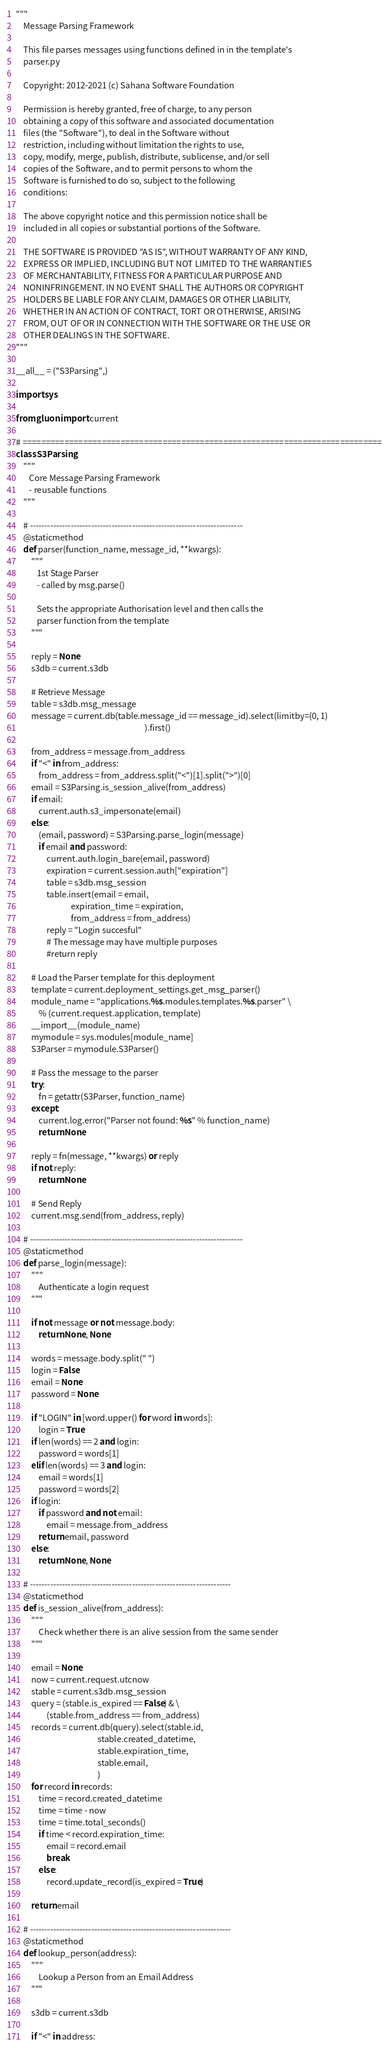<code> <loc_0><loc_0><loc_500><loc_500><_Python_>"""
    Message Parsing Framework

    This file parses messages using functions defined in in the template's
    parser.py

    Copyright: 2012-2021 (c) Sahana Software Foundation

    Permission is hereby granted, free of charge, to any person
    obtaining a copy of this software and associated documentation
    files (the "Software"), to deal in the Software without
    restriction, including without limitation the rights to use,
    copy, modify, merge, publish, distribute, sublicense, and/or sell
    copies of the Software, and to permit persons to whom the
    Software is furnished to do so, subject to the following
    conditions:

    The above copyright notice and this permission notice shall be
    included in all copies or substantial portions of the Software.

    THE SOFTWARE IS PROVIDED "AS IS", WITHOUT WARRANTY OF ANY KIND,
    EXPRESS OR IMPLIED, INCLUDING BUT NOT LIMITED TO THE WARRANTIES
    OF MERCHANTABILITY, FITNESS FOR A PARTICULAR PURPOSE AND
    NONINFRINGEMENT. IN NO EVENT SHALL THE AUTHORS OR COPYRIGHT
    HOLDERS BE LIABLE FOR ANY CLAIM, DAMAGES OR OTHER LIABILITY,
    WHETHER IN AN ACTION OF CONTRACT, TORT OR OTHERWISE, ARISING
    FROM, OUT OF OR IN CONNECTION WITH THE SOFTWARE OR THE USE OR
    OTHER DEALINGS IN THE SOFTWARE.
"""

__all__ = ("S3Parsing",)

import sys

from gluon import current

# =============================================================================
class S3Parsing:
    """
       Core Message Parsing Framework
       - reusable functions
    """

    # -------------------------------------------------------------------------
    @staticmethod
    def parser(function_name, message_id, **kwargs):
        """
           1st Stage Parser
           - called by msg.parse()

           Sets the appropriate Authorisation level and then calls the
           parser function from the template
        """

        reply = None
        s3db = current.s3db

        # Retrieve Message
        table = s3db.msg_message
        message = current.db(table.message_id == message_id).select(limitby=(0, 1)
                                                                    ).first()

        from_address = message.from_address
        if "<" in from_address:
            from_address = from_address.split("<")[1].split(">")[0]
        email = S3Parsing.is_session_alive(from_address)
        if email:
            current.auth.s3_impersonate(email)
        else:
            (email, password) = S3Parsing.parse_login(message)
            if email and password:
                current.auth.login_bare(email, password)
                expiration = current.session.auth["expiration"]
                table = s3db.msg_session
                table.insert(email = email,
                             expiration_time = expiration,
                             from_address = from_address)
                reply = "Login succesful"
                # The message may have multiple purposes
                #return reply

        # Load the Parser template for this deployment
        template = current.deployment_settings.get_msg_parser()
        module_name = "applications.%s.modules.templates.%s.parser" \
            % (current.request.application, template)
        __import__(module_name)
        mymodule = sys.modules[module_name]
        S3Parser = mymodule.S3Parser()

        # Pass the message to the parser
        try:
            fn = getattr(S3Parser, function_name)
        except:
            current.log.error("Parser not found: %s" % function_name)
            return None

        reply = fn(message, **kwargs) or reply
        if not reply:
            return None

        # Send Reply
        current.msg.send(from_address, reply)

    # -------------------------------------------------------------------------
    @staticmethod
    def parse_login(message):
        """
            Authenticate a login request
        """

        if not message or not message.body:
            return None, None

        words = message.body.split(" ")
        login = False
        email = None
        password = None

        if "LOGIN" in [word.upper() for word in words]:
            login = True
        if len(words) == 2 and login:
            password = words[1]
        elif len(words) == 3 and login:
            email = words[1]
            password = words[2]
        if login:
            if password and not email:
                email = message.from_address
            return email, password
        else:
            return None, None

    # ---------------------------------------------------------------------
    @staticmethod
    def is_session_alive(from_address):
        """
            Check whether there is an alive session from the same sender
        """

        email = None
        now = current.request.utcnow
        stable = current.s3db.msg_session
        query = (stable.is_expired == False) & \
                (stable.from_address == from_address)
        records = current.db(query).select(stable.id,
                                           stable.created_datetime,
                                           stable.expiration_time,
                                           stable.email,
                                           )
        for record in records:
            time = record.created_datetime
            time = time - now
            time = time.total_seconds()
            if time < record.expiration_time:
                email = record.email
                break
            else:
                record.update_record(is_expired = True)

        return email

    # ---------------------------------------------------------------------
    @staticmethod
    def lookup_person(address):
        """
            Lookup a Person from an Email Address
        """

        s3db = current.s3db

        if "<" in address:</code> 